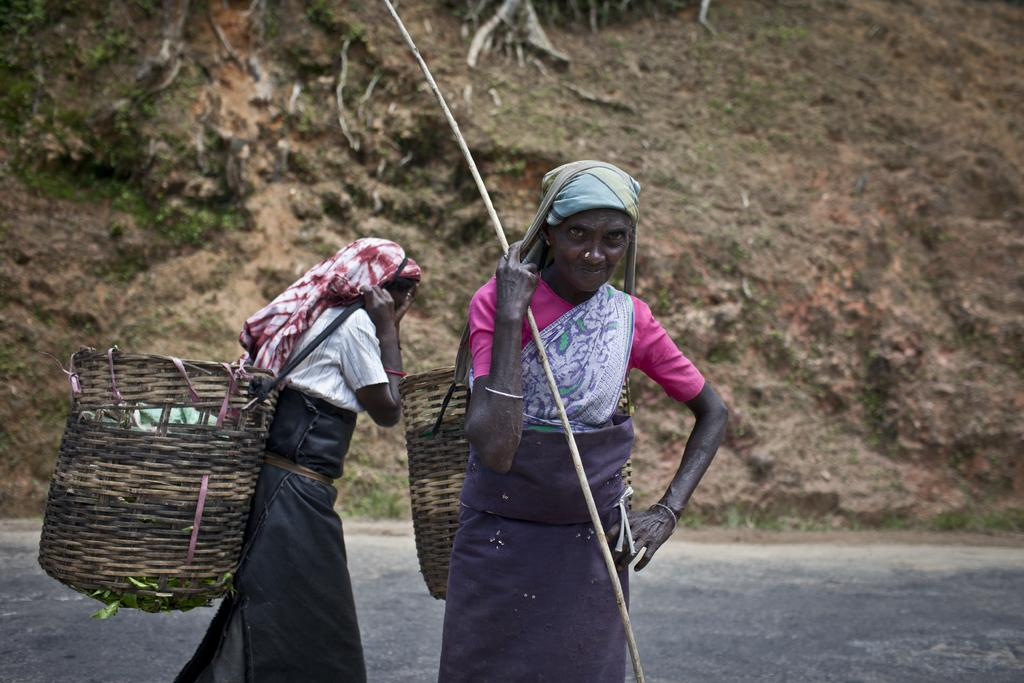How many women are present in the image? There are two women in the image. What are the women doing in the image? The women are holding a basket on their backs. What else can be seen in the women's hands? One of the women is holding a stick in her hand. What can be seen in the background of the image? There is a hill visible in the background of the image. Where is the zoo located in the image? There is no zoo present in the image. What type of oatmeal is being served in the image? There is no oatmeal present in the image. 